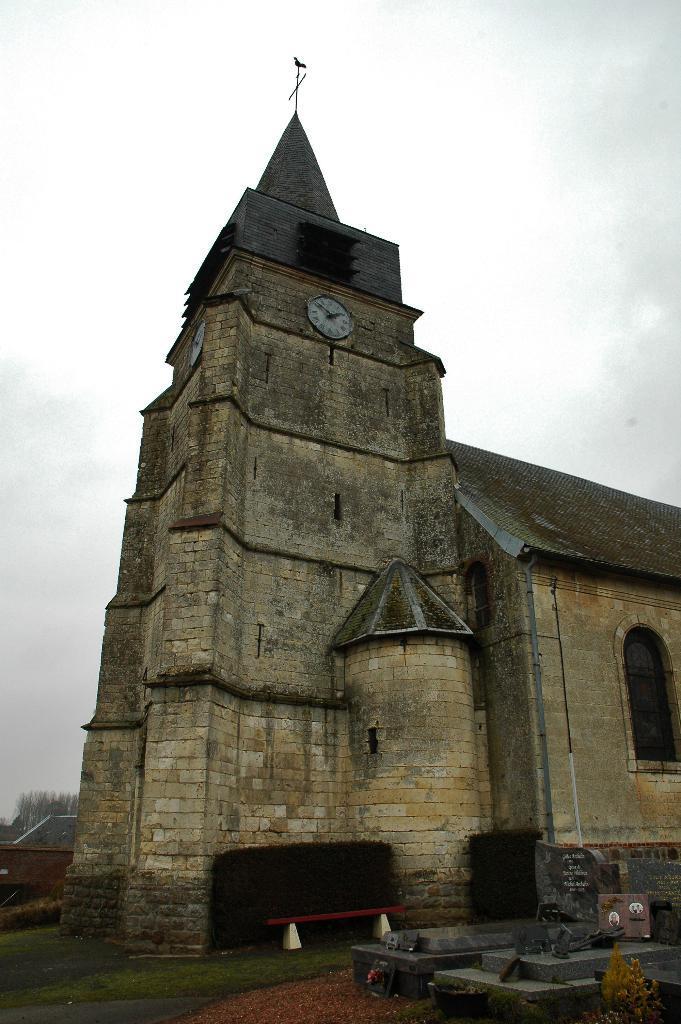Please provide a concise description of this image. There is a clock tower in the middle of this image and the sky is in the background. 